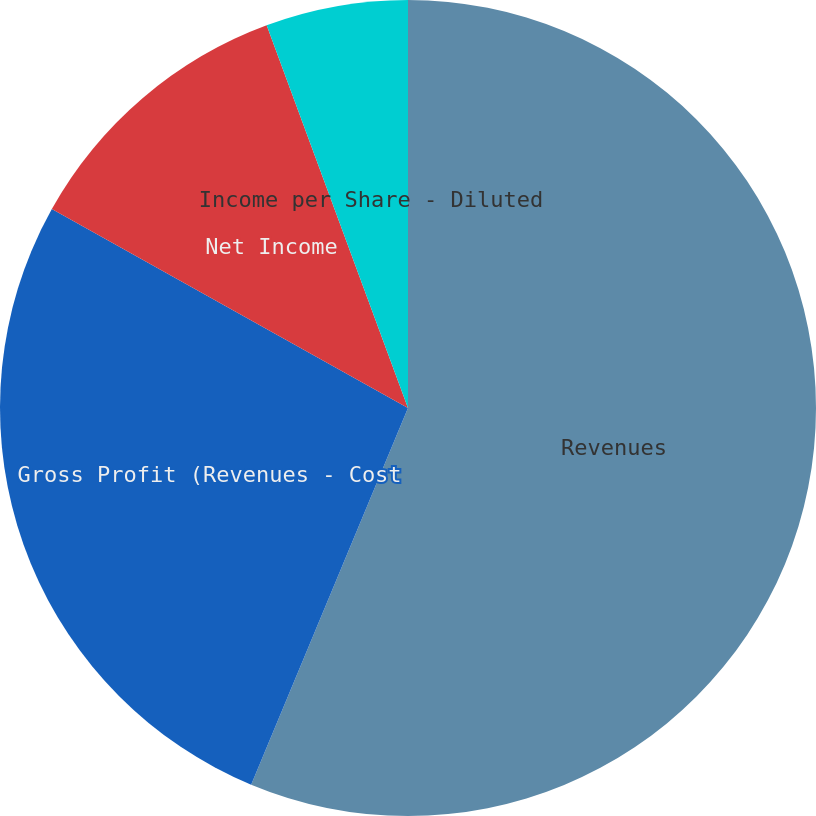<chart> <loc_0><loc_0><loc_500><loc_500><pie_chart><fcel>Revenues<fcel>Gross Profit (Revenues - Cost<fcel>Net Income<fcel>Income per Share - Basic<fcel>Income per Share - Diluted<nl><fcel>56.28%<fcel>26.83%<fcel>11.26%<fcel>0.0%<fcel>5.63%<nl></chart> 